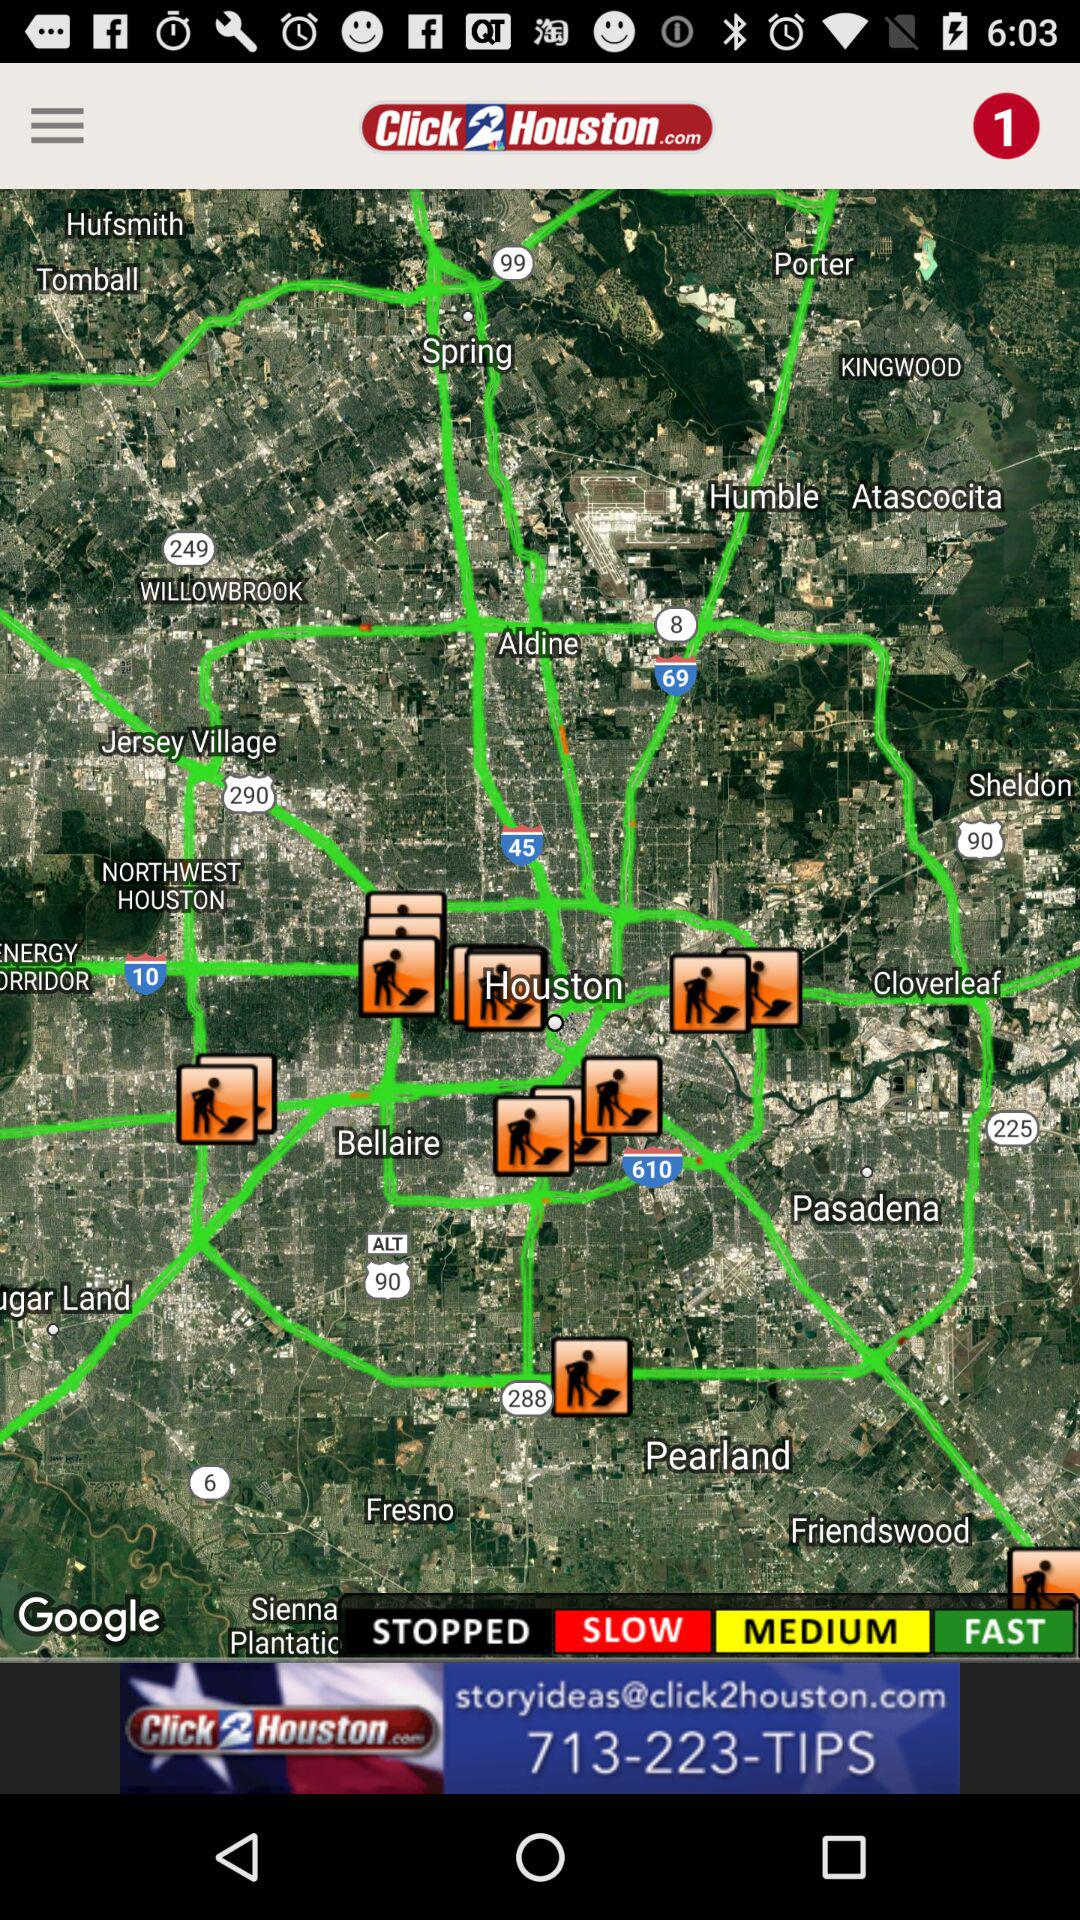What is the app name? The app name is "Click2Houston.com". 